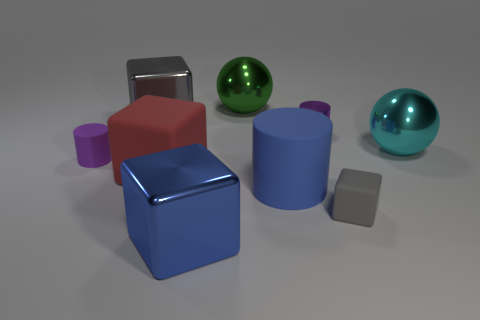How big is the metallic sphere in front of the purple object right of the blue shiny object?
Your response must be concise. Large. There is a cylinder that is to the right of the purple rubber thing and left of the small metallic thing; what is its color?
Your response must be concise. Blue. Is the purple matte thing the same shape as the cyan thing?
Give a very brief answer. No. The object that is the same color as the large cylinder is what size?
Make the answer very short. Large. The cyan shiny thing that is right of the large matte object that is left of the green shiny sphere is what shape?
Provide a short and direct response. Sphere. Does the large gray object have the same shape as the metal thing in front of the small purple matte thing?
Make the answer very short. Yes. The shiny cylinder that is the same size as the purple matte cylinder is what color?
Offer a terse response. Purple. Are there fewer blue shiny cubes that are to the right of the small purple metal cylinder than large red cubes that are left of the large green metal sphere?
Give a very brief answer. Yes. There is a large thing that is behind the metal block behind the small purple cylinder in front of the purple metal thing; what is its shape?
Ensure brevity in your answer.  Sphere. There is a large shiny block behind the big red block; is its color the same as the small rubber thing on the right side of the big gray shiny cube?
Keep it short and to the point. Yes. 